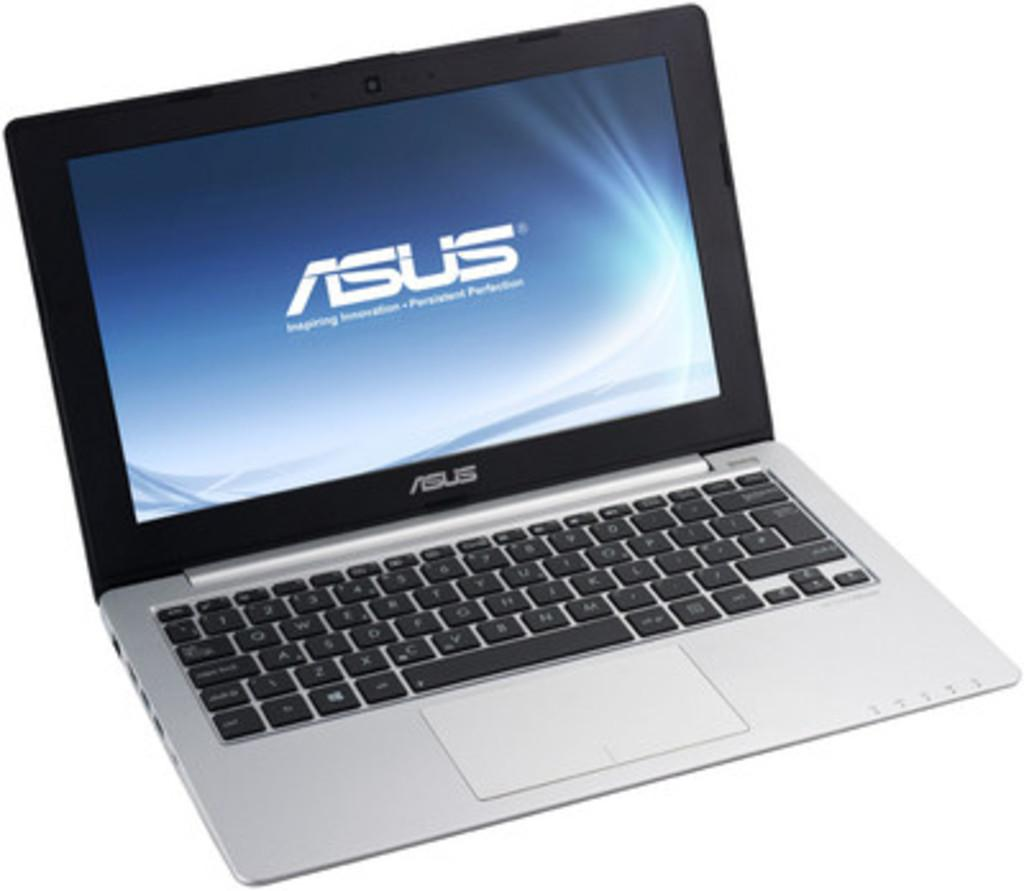Provide a one-sentence caption for the provided image. An open laptop displays the ASUS logo on a blue screen. 